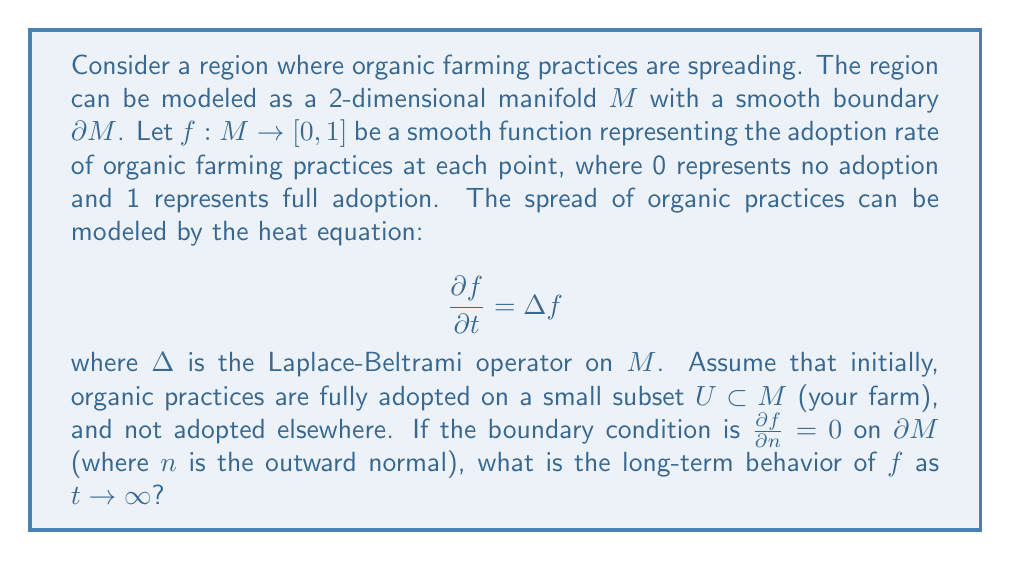Give your solution to this math problem. To solve this problem, we need to consider the properties of the heat equation on a compact manifold with Neumann boundary conditions:

1) The heat equation $\frac{\partial f}{\partial t} = \Delta f$ describes diffusion processes, which in this case models the spread of organic farming practices.

2) The Neumann boundary condition $\frac{\partial f}{\partial n} = 0$ on $\partial M$ means that there's no flux across the boundary. In our context, this implies that the adoption of organic practices is neither influenced by nor influencing areas outside the region.

3) For a compact manifold $M$ with smooth boundary $\partial M$, the spectrum of the Laplace-Beltrami operator $\Delta$ with Neumann boundary conditions is discrete and non-positive:

   $$0 = \lambda_0 > \lambda_1 \geq \lambda_2 \geq \cdots$$

   where $\lambda_0 = 0$ corresponds to constant functions.

4) The solution to the heat equation can be expressed as a series:

   $$f(x,t) = \sum_{i=0}^{\infty} c_i e^{\lambda_i t} \phi_i(x)$$

   where $\phi_i$ are the eigenfunctions of $\Delta$.

5) As $t \to \infty$, all terms with $\lambda_i < 0$ decay exponentially, leaving only the constant term corresponding to $\lambda_0 = 0$.

6) The constant term is determined by the conservation of the integral of $f$ over $M$, which is preserved by the heat equation with Neumann boundary conditions:

   $$\int_M f(x,t) dV = \text{constant} = \int_M f(x,0) dV$$

7) Initially, $f$ is 1 on $U$ and 0 elsewhere, so:

   $$\int_M f(x,0) dV = \text{Vol}(U)$$

8) As $t \to \infty$, $f$ approaches a constant value $c$ such that:

   $$c \cdot \text{Vol}(M) = \text{Vol}(U)$$

Therefore, the long-term behavior of $f$ as $t \to \infty$ is a constant function:

$$f(x,\infty) = \frac{\text{Vol}(U)}{\text{Vol}(M)}$$

This represents a uniform adoption rate across the entire region, determined by the ratio of the initial adoption area to the total area.
Answer: As $t \to \infty$, $f(x,t)$ approaches a constant function $f(x,\infty) = \frac{\text{Vol}(U)}{\text{Vol}(M)}$, where $\text{Vol}(U)$ is the volume (area) of the initial adoption region and $\text{Vol}(M)$ is the total volume (area) of the region. 